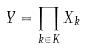Convert formula to latex. <formula><loc_0><loc_0><loc_500><loc_500>Y = \prod _ { k \in K } X _ { k }</formula> 